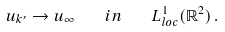<formula> <loc_0><loc_0><loc_500><loc_500>u _ { k ^ { \prime } } \rightarrow u _ { \infty } \quad i n \quad L ^ { 1 } _ { l o c } ( \mathbb { R } ^ { 2 } ) \, .</formula> 